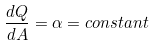Convert formula to latex. <formula><loc_0><loc_0><loc_500><loc_500>\frac { d Q } { d A } = \alpha = c o n s t a n t</formula> 